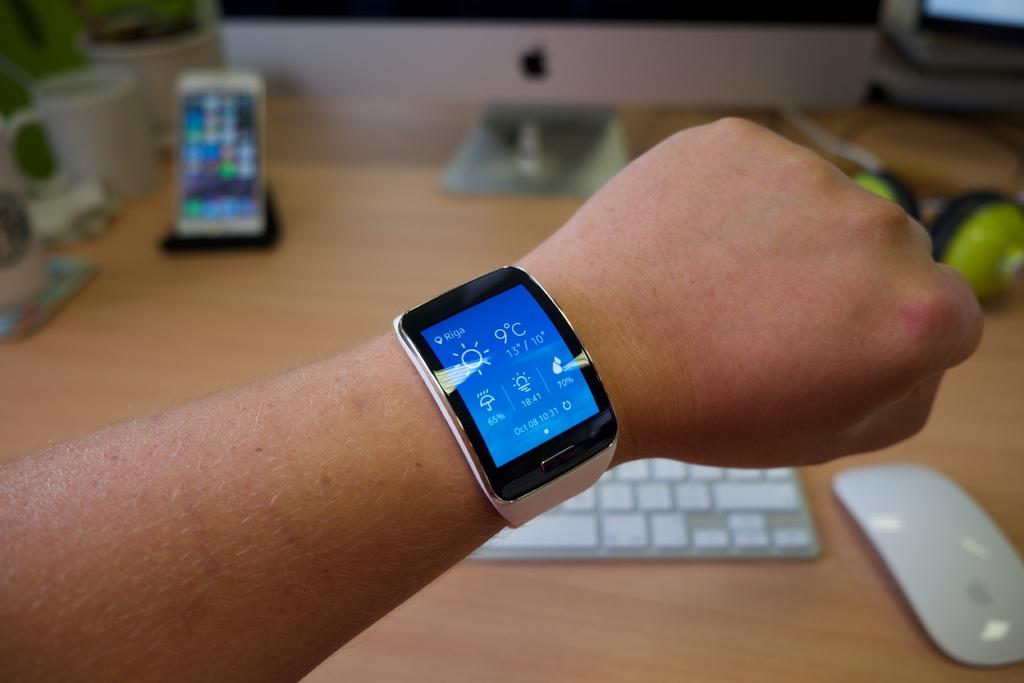<image>
Present a compact description of the photo's key features. The wrist wear watch that displays the date of October and the time and weather on the display. 